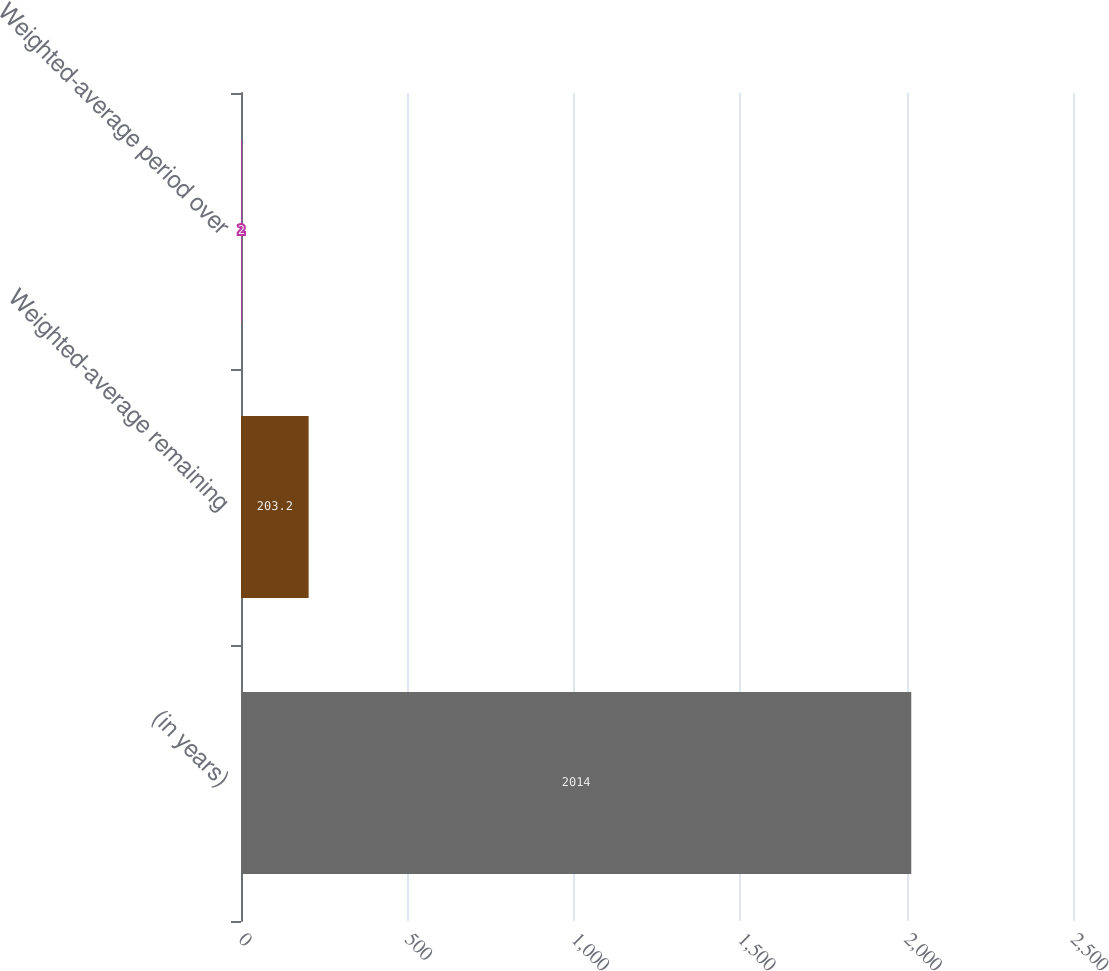Convert chart to OTSL. <chart><loc_0><loc_0><loc_500><loc_500><bar_chart><fcel>(in years)<fcel>Weighted-average remaining<fcel>Weighted-average period over<nl><fcel>2014<fcel>203.2<fcel>2<nl></chart> 